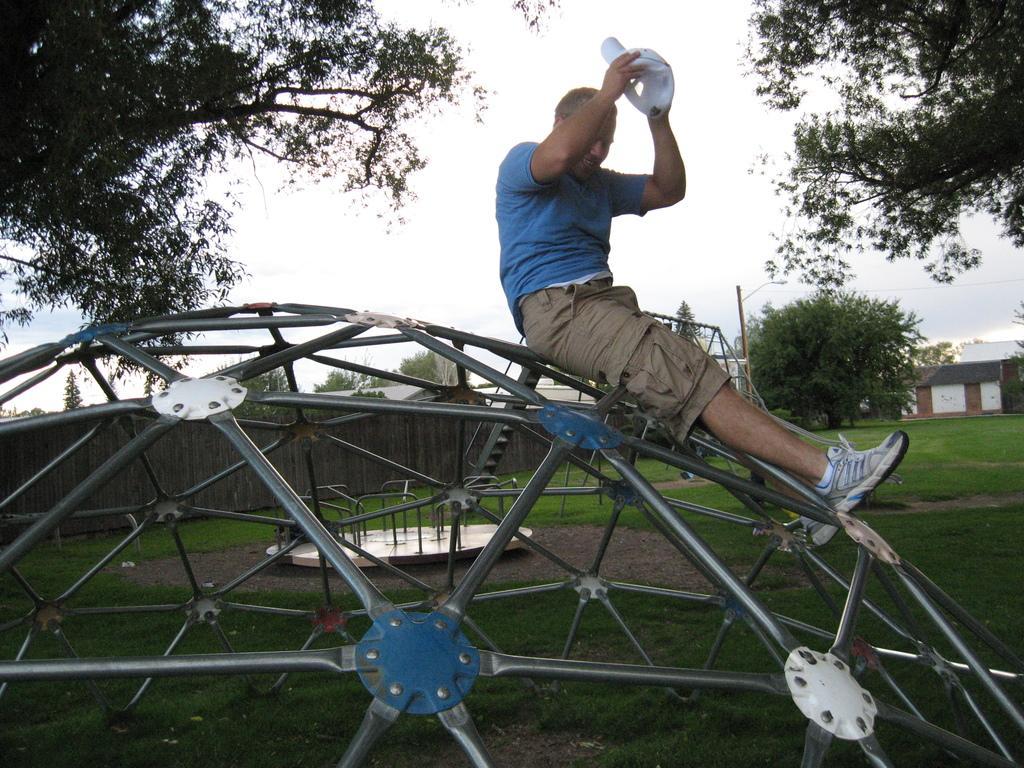How would you summarize this image in a sentence or two? Here we can see a man sitting on a metal object and he is holding a cap with his hands. Here we can see grass, trees, wall, and a house. In the background there is sky. 